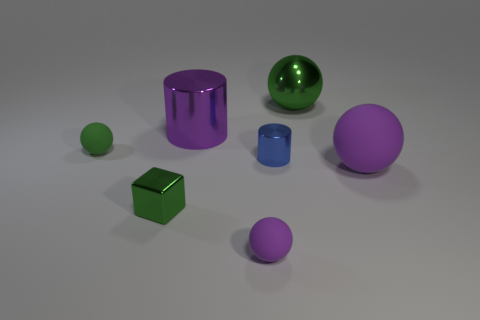There is a purple matte thing that is to the left of the large rubber object; how many tiny objects are on the left side of it?
Ensure brevity in your answer.  2. There is a purple object that is behind the green ball in front of the large purple thing that is behind the large rubber sphere; what is its shape?
Provide a short and direct response. Cylinder. There is a matte object that is the same color as the large shiny ball; what size is it?
Offer a very short reply. Small. What number of objects are either small green rubber spheres or large matte things?
Offer a very short reply. 2. The metal object that is the same size as the purple cylinder is what color?
Your response must be concise. Green. Do the big rubber thing and the tiny green shiny object that is in front of the big green object have the same shape?
Keep it short and to the point. No. How many things are tiny blue metallic objects that are to the left of the big purple matte sphere or large objects behind the tiny green matte thing?
Provide a succinct answer. 3. What is the shape of the other rubber thing that is the same color as the big matte object?
Give a very brief answer. Sphere. The big metal object on the right side of the large shiny cylinder has what shape?
Make the answer very short. Sphere. There is a small shiny object behind the large rubber ball; is it the same shape as the small green metal object?
Provide a succinct answer. No. 